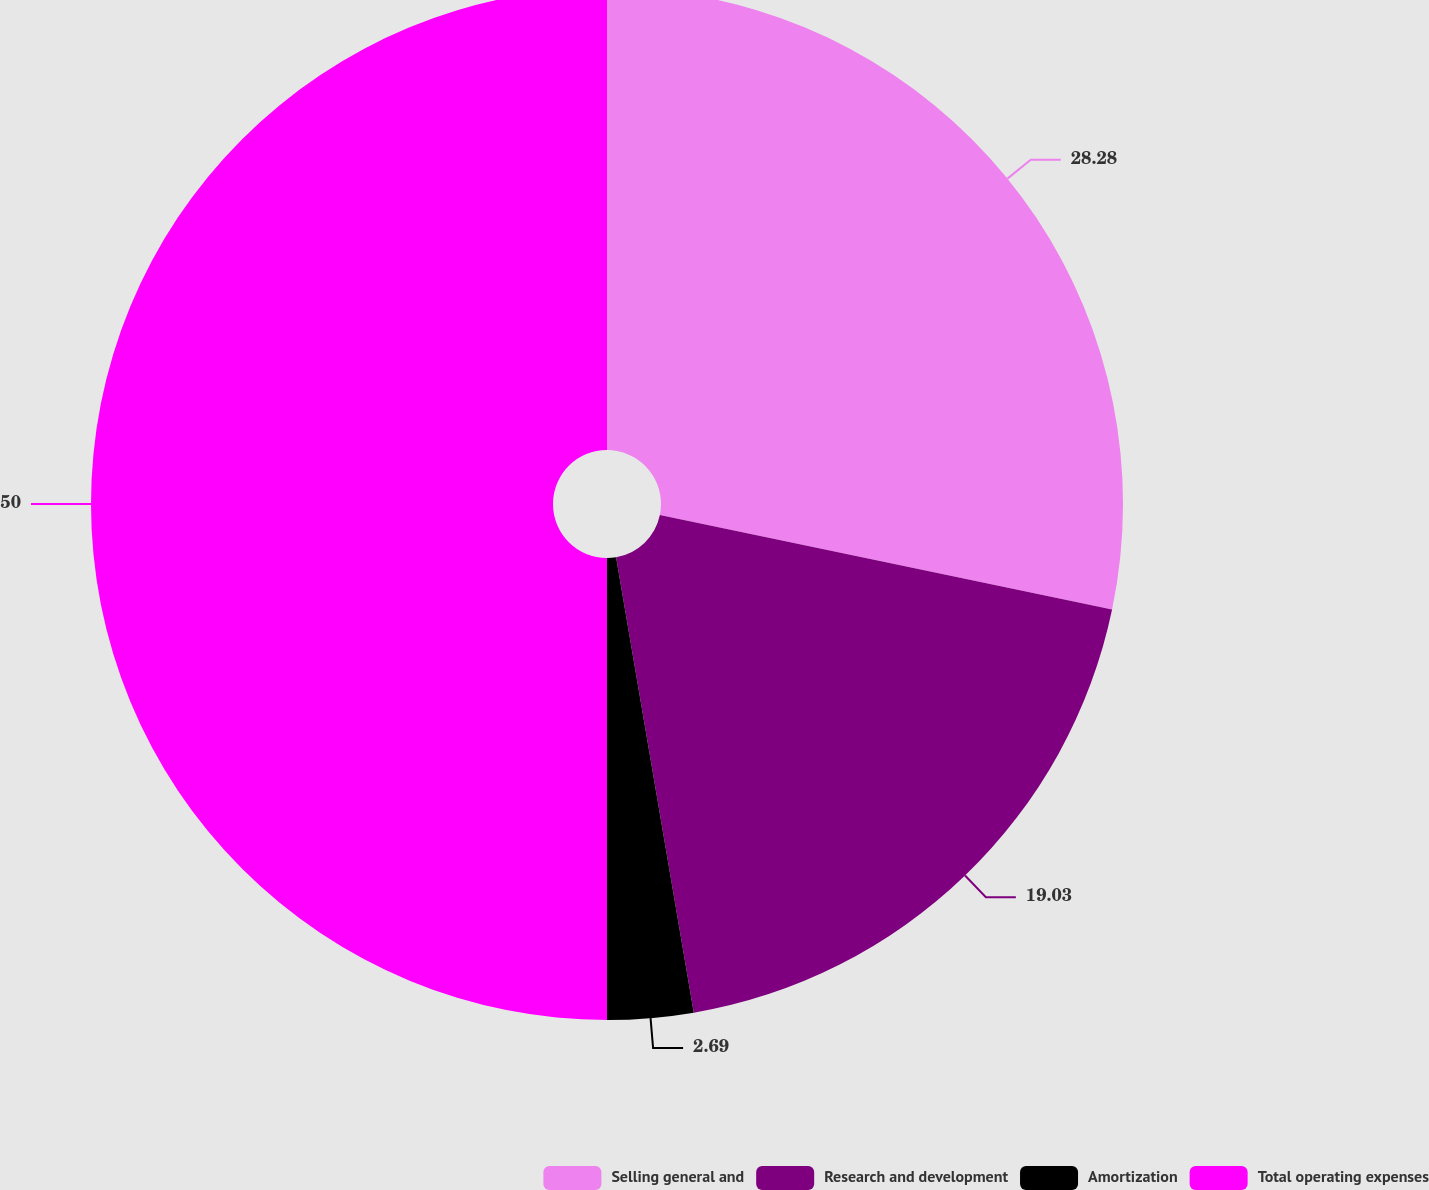<chart> <loc_0><loc_0><loc_500><loc_500><pie_chart><fcel>Selling general and<fcel>Research and development<fcel>Amortization<fcel>Total operating expenses<nl><fcel>28.28%<fcel>19.03%<fcel>2.69%<fcel>50.0%<nl></chart> 